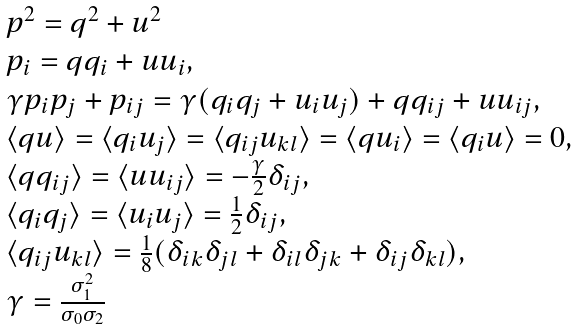Convert formula to latex. <formula><loc_0><loc_0><loc_500><loc_500>\begin{array} { l } p ^ { 2 } = q ^ { 2 } + u ^ { 2 } \\ p _ { i } = q q _ { i } + u u _ { i } , \\ \gamma p _ { i } p _ { j } + p _ { i j } = \gamma ( q _ { i } q _ { j } + u _ { i } u _ { j } ) + q q _ { i j } + u u _ { i j } , \\ \langle q u \rangle = \langle q _ { i } u _ { j } \rangle = \langle q _ { i j } u _ { k l } \rangle = \langle q u _ { i } \rangle = \langle q _ { i } u \rangle = 0 , \\ \langle q q _ { i j } \rangle = \langle u u _ { i j } \rangle = - \frac { \gamma } { 2 } \delta _ { i j } , \\ \langle q _ { i } q _ { j } \rangle = \langle u _ { i } u _ { j } \rangle = \frac { 1 } { 2 } \delta _ { i j } , \\ \langle q _ { i j } u _ { k l } \rangle = \frac { 1 } { 8 } ( \delta _ { i k } \delta _ { j l } + \delta _ { i l } \delta _ { j k } + \delta _ { i j } \delta _ { k l } ) , \\ \gamma = \frac { \sigma _ { 1 } ^ { 2 } } { \sigma _ { 0 } \sigma _ { 2 } } \end{array}</formula> 